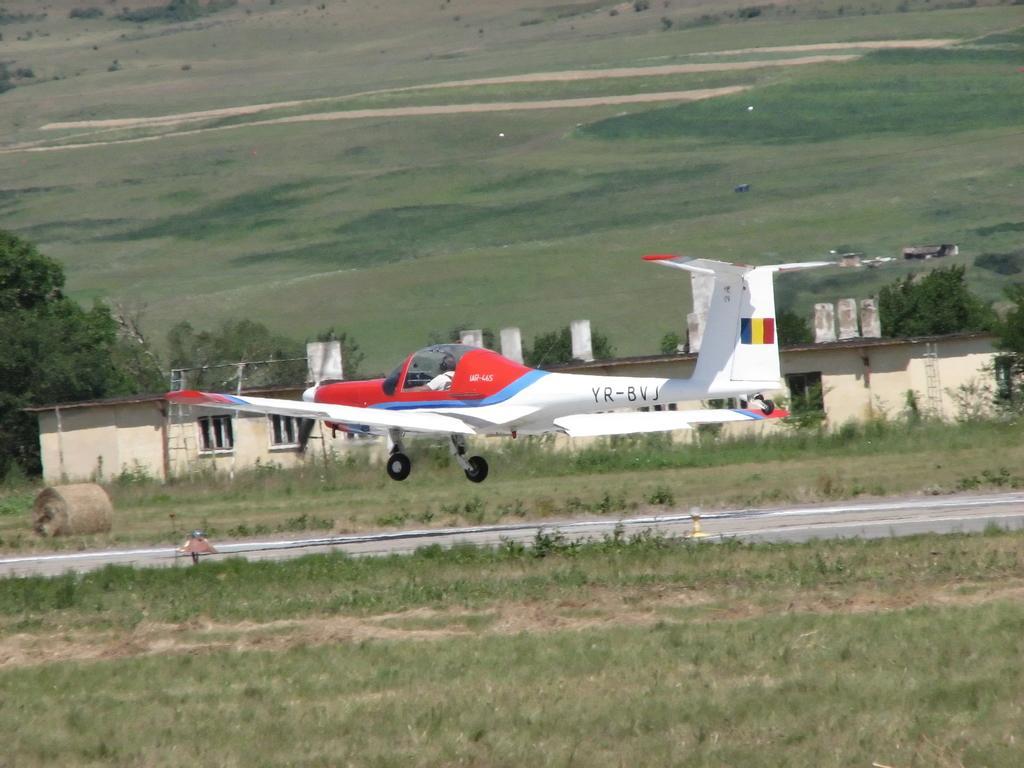In one or two sentences, can you explain what this image depicts? In this image we can see a person sitting in an airplane. We can also see a runway, grass, plants, a roller on the ground, a house with windows and a group of trees. 